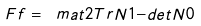<formula> <loc_0><loc_0><loc_500><loc_500>\ F f = \ m a t 2 { T r N } { 1 } { - d e t N } { 0 }</formula> 